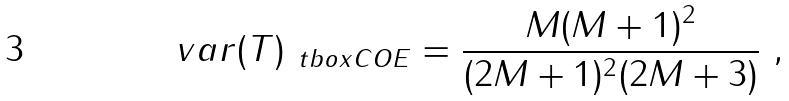<formula> <loc_0><loc_0><loc_500><loc_500>v a r ( T ) _ { \ t b o x { C O E } } = \frac { M ( M + 1 ) ^ { 2 } } { ( 2 M + 1 ) ^ { 2 } ( 2 M + 3 ) } \ ,</formula> 